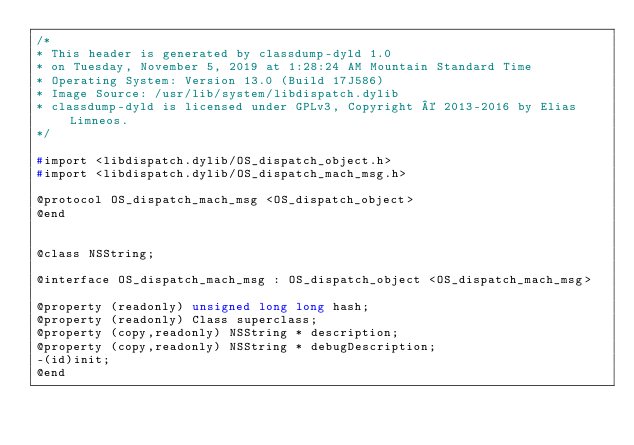<code> <loc_0><loc_0><loc_500><loc_500><_C_>/*
* This header is generated by classdump-dyld 1.0
* on Tuesday, November 5, 2019 at 1:28:24 AM Mountain Standard Time
* Operating System: Version 13.0 (Build 17J586)
* Image Source: /usr/lib/system/libdispatch.dylib
* classdump-dyld is licensed under GPLv3, Copyright © 2013-2016 by Elias Limneos.
*/

#import <libdispatch.dylib/OS_dispatch_object.h>
#import <libdispatch.dylib/OS_dispatch_mach_msg.h>

@protocol OS_dispatch_mach_msg <OS_dispatch_object>
@end


@class NSString;

@interface OS_dispatch_mach_msg : OS_dispatch_object <OS_dispatch_mach_msg>

@property (readonly) unsigned long long hash; 
@property (readonly) Class superclass; 
@property (copy,readonly) NSString * description; 
@property (copy,readonly) NSString * debugDescription; 
-(id)init;
@end

</code> 